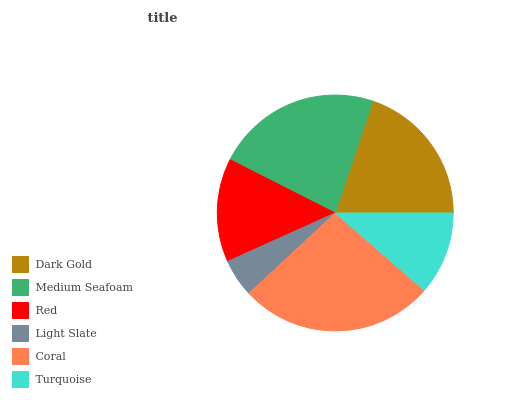Is Light Slate the minimum?
Answer yes or no. Yes. Is Coral the maximum?
Answer yes or no. Yes. Is Medium Seafoam the minimum?
Answer yes or no. No. Is Medium Seafoam the maximum?
Answer yes or no. No. Is Medium Seafoam greater than Dark Gold?
Answer yes or no. Yes. Is Dark Gold less than Medium Seafoam?
Answer yes or no. Yes. Is Dark Gold greater than Medium Seafoam?
Answer yes or no. No. Is Medium Seafoam less than Dark Gold?
Answer yes or no. No. Is Dark Gold the high median?
Answer yes or no. Yes. Is Red the low median?
Answer yes or no. Yes. Is Turquoise the high median?
Answer yes or no. No. Is Light Slate the low median?
Answer yes or no. No. 